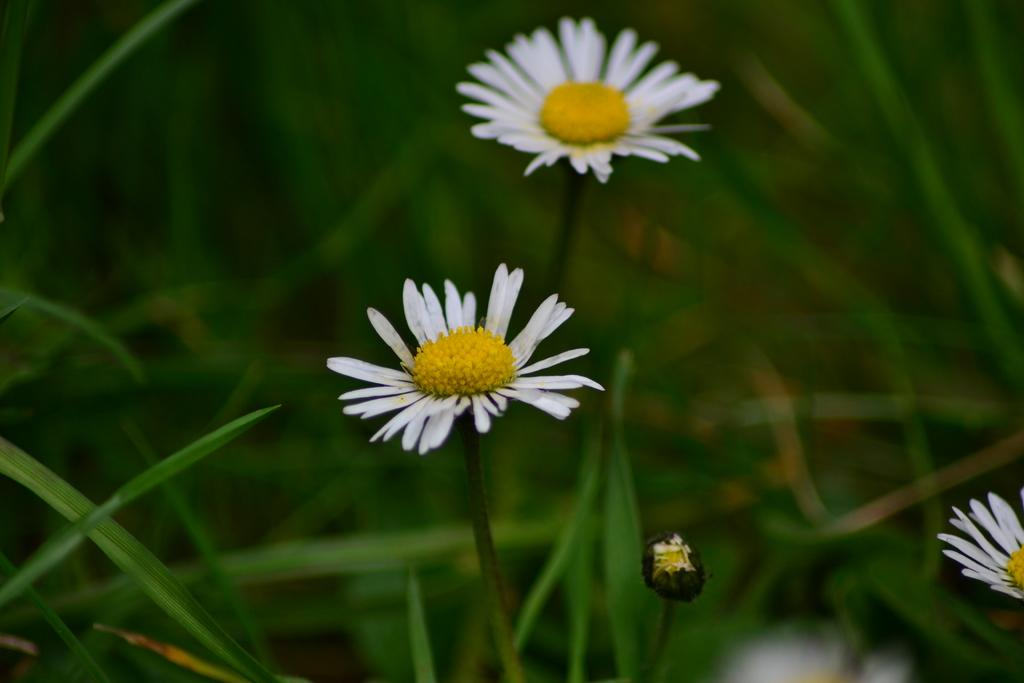How many flowers are present in the image? There are two flowers in the image. What are the colors of the flowers? One flower is white in color, and the other flower is yellow in color. What can be seen in the background of the image? There is grass visible in the background of the image. What type of boat is visible in the image? There is no boat present in the image; it features two flowers and grass in the background. What does the yellow flower smell like in the image? The image does not provide information about the smell of the flowers, so it cannot be determined from the image. 